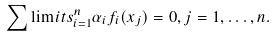Convert formula to latex. <formula><loc_0><loc_0><loc_500><loc_500>\sum \lim i t s _ { i = 1 } ^ { n } \alpha _ { i } f _ { i } ( x _ { j } ) = 0 , j = 1 , \dots , n .</formula> 